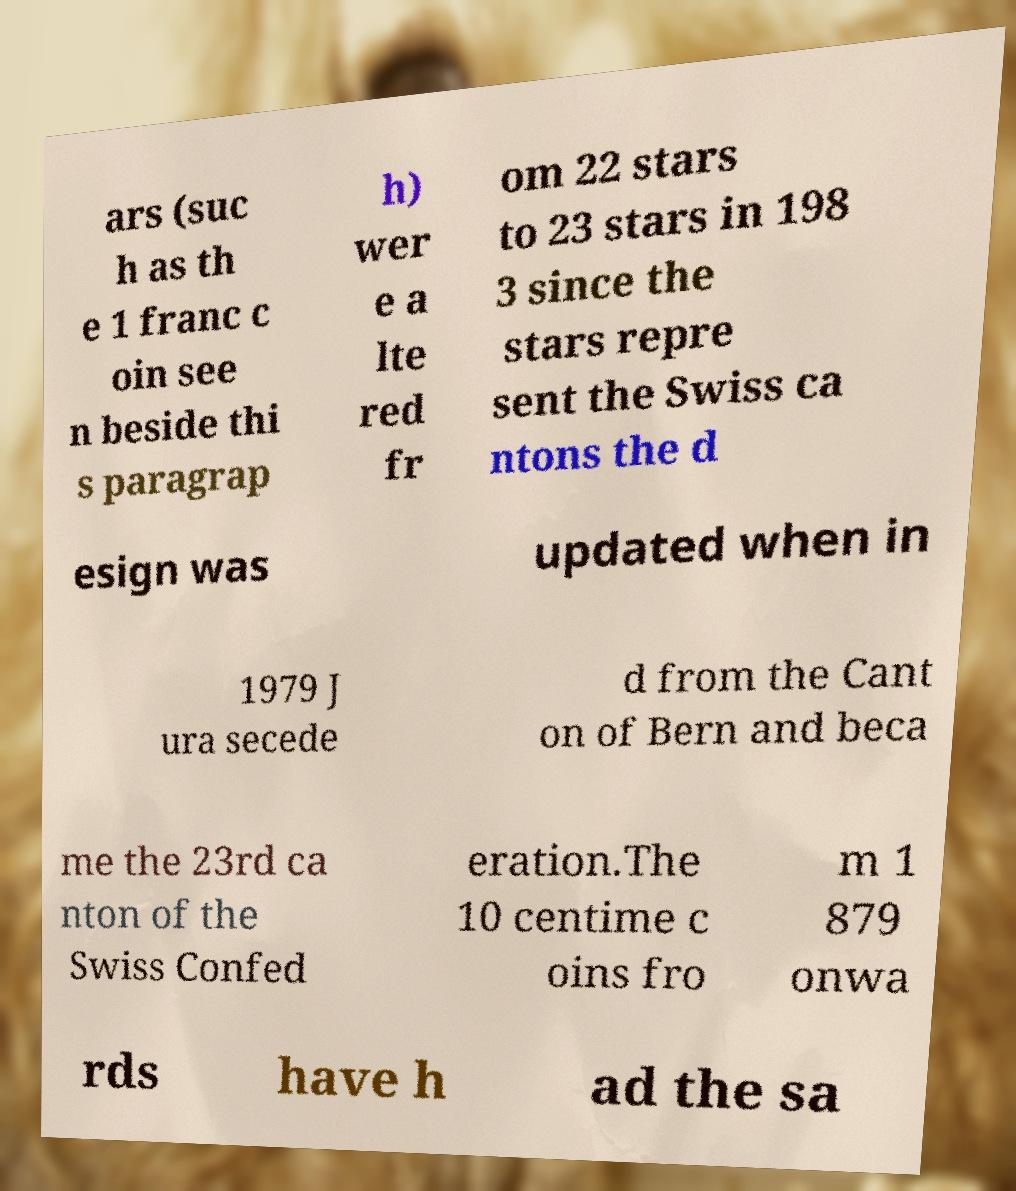Please read and relay the text visible in this image. What does it say? ars (suc h as th e 1 franc c oin see n beside thi s paragrap h) wer e a lte red fr om 22 stars to 23 stars in 198 3 since the stars repre sent the Swiss ca ntons the d esign was updated when in 1979 J ura secede d from the Cant on of Bern and beca me the 23rd ca nton of the Swiss Confed eration.The 10 centime c oins fro m 1 879 onwa rds have h ad the sa 